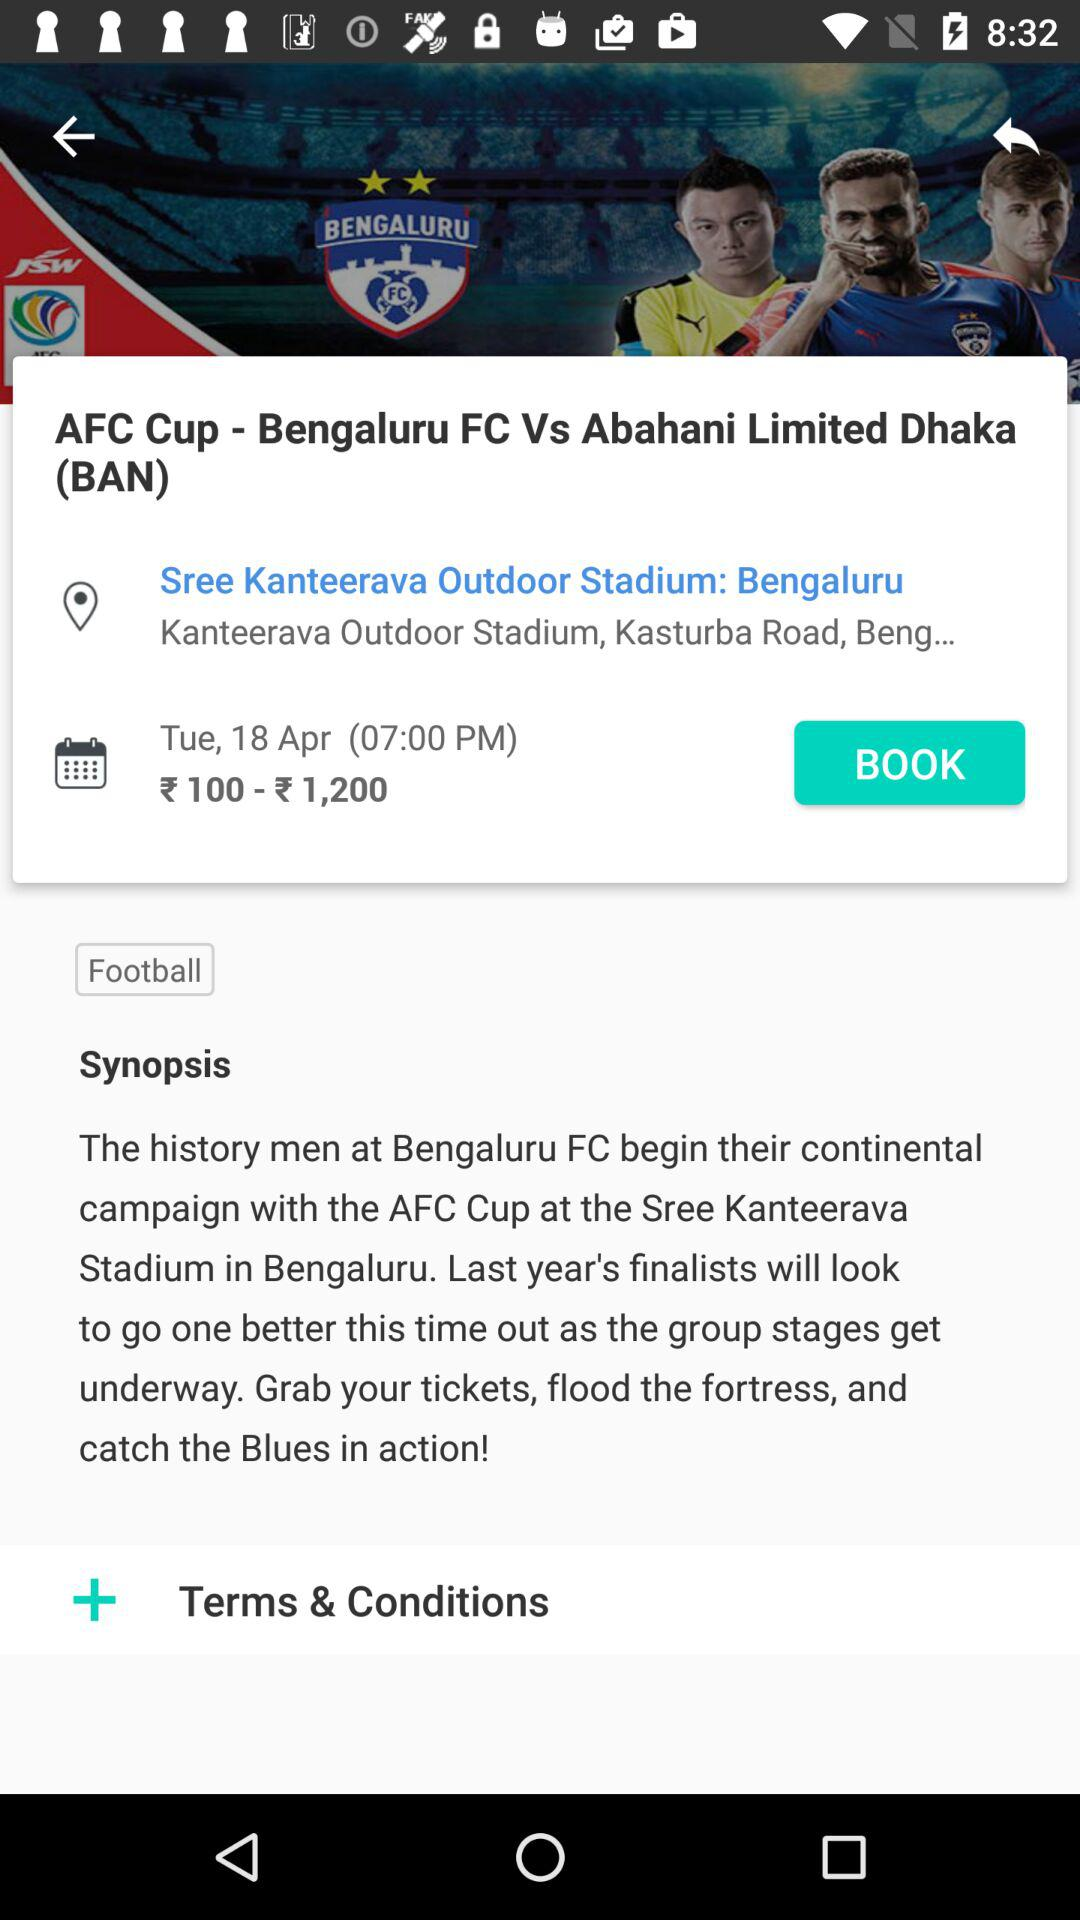What is the shown location? The location is Kanteerava Outdoor Stadium, Kasturba Road, Bengaluru. 